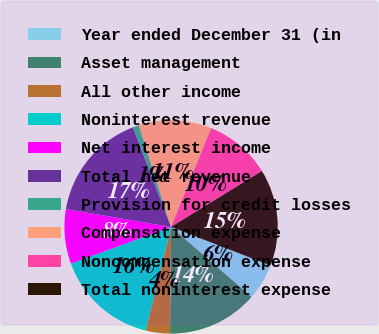Convert chart. <chart><loc_0><loc_0><loc_500><loc_500><pie_chart><fcel>Year ended December 31 (in<fcel>Asset management<fcel>All other income<fcel>Noninterest revenue<fcel>Net interest income<fcel>Total net revenue<fcel>Provision for credit losses<fcel>Compensation expense<fcel>Noncompensation expense<fcel>Total noninterest expense<nl><fcel>5.51%<fcel>13.76%<fcel>3.68%<fcel>15.59%<fcel>8.26%<fcel>16.51%<fcel>0.93%<fcel>11.01%<fcel>10.09%<fcel>14.67%<nl></chart> 